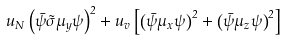Convert formula to latex. <formula><loc_0><loc_0><loc_500><loc_500>u _ { N } \left ( \bar { \psi } \vec { \sigma } \mu _ { y } \psi \right ) ^ { 2 } + u _ { v } \left [ \left ( \bar { \psi } \mu _ { x } \psi \right ) ^ { 2 } + \left ( \bar { \psi } \mu _ { z } \psi \right ) ^ { 2 } \right ]</formula> 